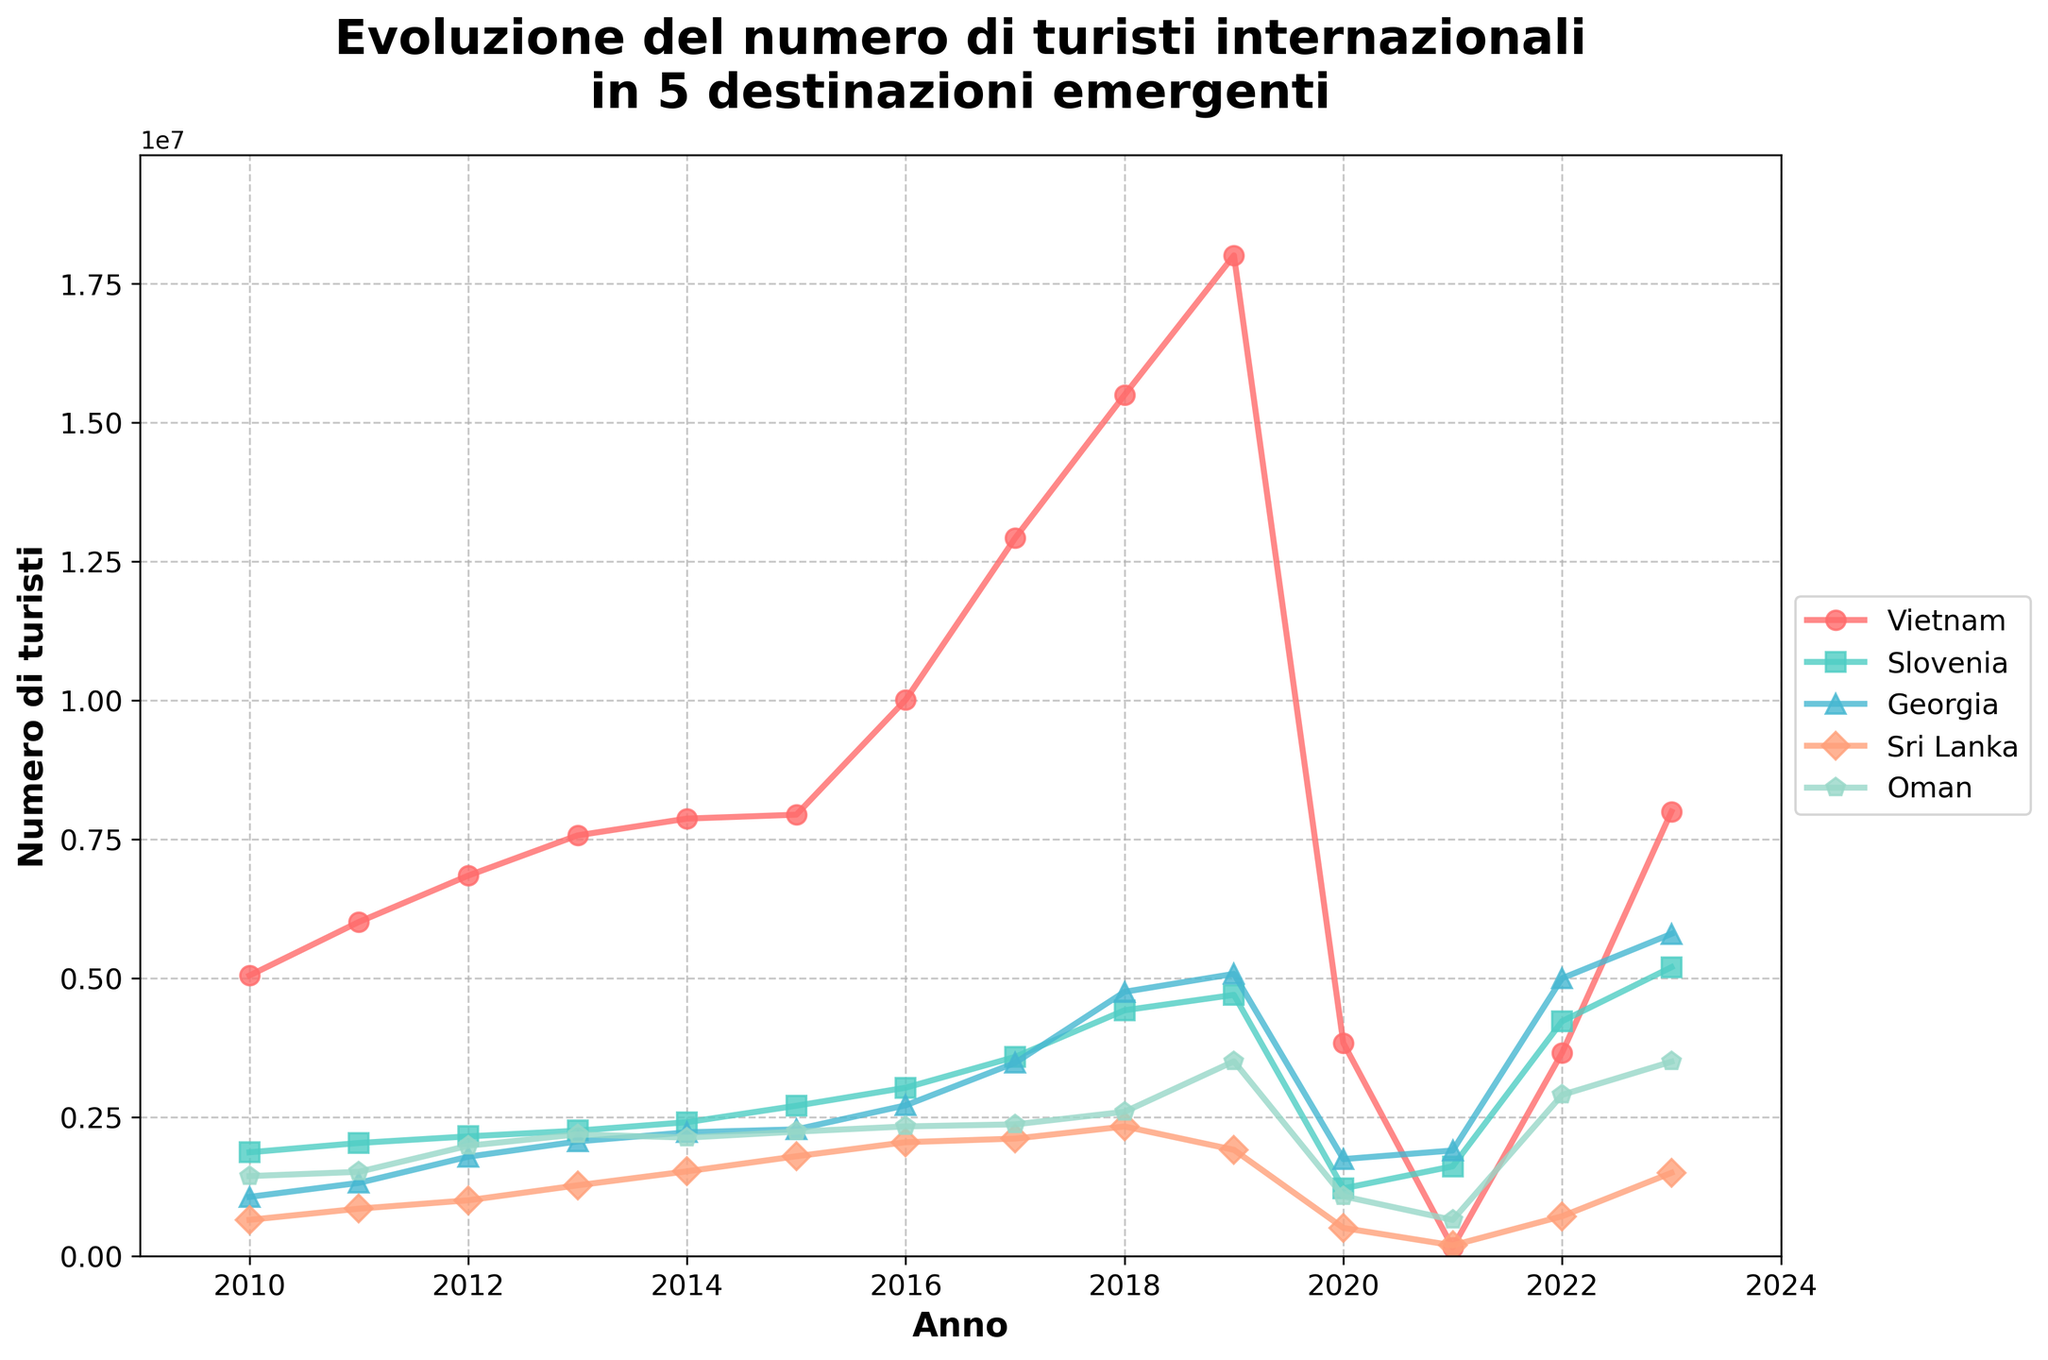Which destination showed the highest number of international tourists in 2019? In 2019, Vietnam had the highest number of international tourists at 18,009,000. This is apparent from the line height, which reaches its peak in 2019.
Answer: Vietnam Which country experienced the most significant drop in tourist numbers from 2019 to 2020? Comparing the lines from 2019 to 2020, Vietnam shows a drastic drop from 18,009,000 to 3,837,000, indicating the most significant decline.
Answer: Vietnam Between 2010 and 2023, which destination saw the most consistent growth in international tourist numbers? By observing the trendlines, Georgia shows a consistent upward trend from 1,067,000 in 2010 to 5,800,000 in 2023 with fewer fluctuations compared to others.
Answer: Georgia In which year did Slovenia surpass Georgia in the number of international tourists? The lines for Slovenia and Georgia cross between 2018 and 2019. In 2018, Georgia had 4,757,000 tourists while Slovenia had 4,425,000. In 2019, Slovenia had 4,702,000, surpassing Georgia's 5,080,000. Thus, Slovenia surpassed Georgia between 2018 and 2019.
Answer: 2019 How did the number of tourists in Oman change from 2019 to 2023? In 2019, Oman had 3,506,000 tourists, and this number decreased to 3,500,000 in 2023. This small decrease is evident from the descending line.
Answer: Decreased Calculate the average number of tourists in Vietnam from 2016 to 2019. Sum the tourist numbers for Vietnam from 2016 to 2019: (10,013,000 + 12,922,000 + 15,498,000 + 18,009,000) = 56,442,000. Divide by the 4 years: 56,442,000 / 4 = 14,110,500.
Answer: 14,110,500 Which country had more tourists in 2023, Sri Lanka or Oman? In 2023, Sri Lanka had 1,500,000 tourists, and Oman had 3,500,000 tourists. Oman had more tourists.
Answer: Oman Identify the year with the most significant increase in tourist numbers for Sri Lanka. The most significant increase for Sri Lanka is from 2016 to 2017, where numbers jumped from 2,051,000 to 2,116,000. The steepest upward slope visually represents this.
Answer: 2017 Compare the tourist numbers in Georgia and Sri Lanka in 2022. Which country had more, and by how much? In 2022, Georgia had 5,001,000 tourists, and Sri Lanka had 719,000 tourists. Georgia had 5,001,000 - 719,000 = 4,282,000 more tourists than Sri Lanka.
Answer: Georgia by 4,282,000 